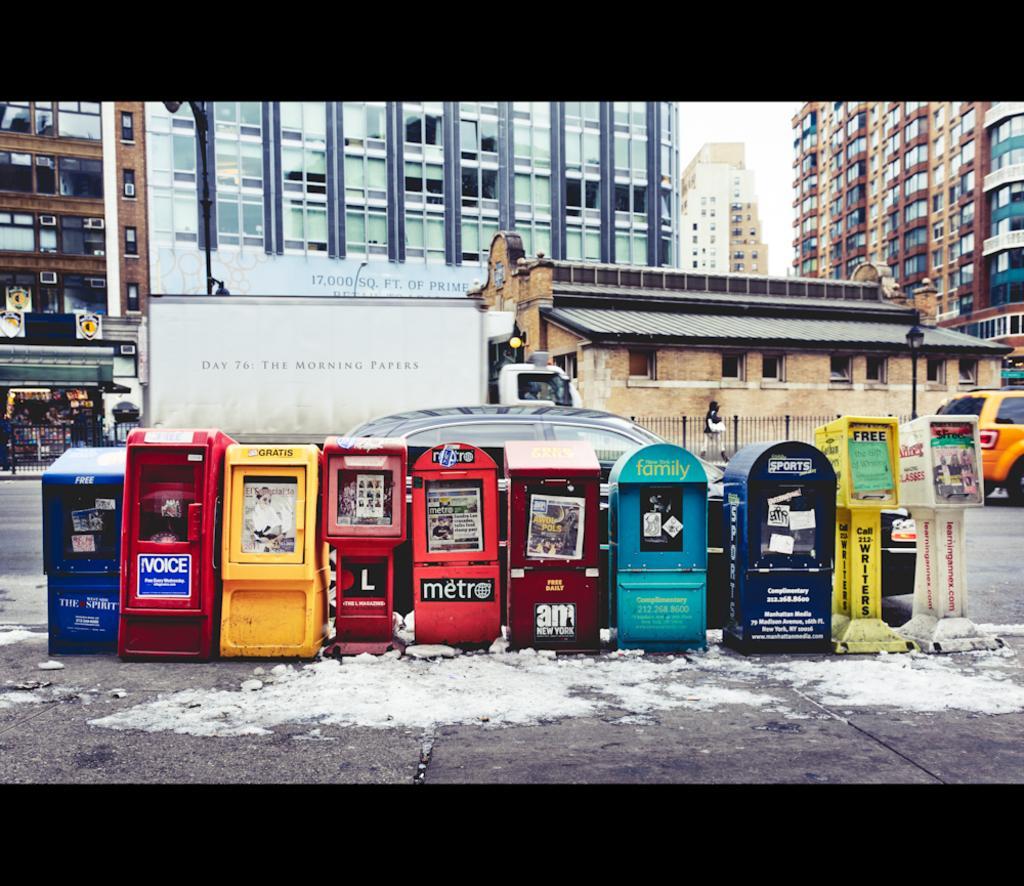Can you describe this image briefly? This image is taken outdoors. At the bottom of the image there is a road and there is a dirt on the road. In the background there are a few buildings. There are many boards with text on them. There is a railing. In the middle of the image a truck is parked on the road. There is a house with walls, windows, doors and a roof. There is a pole with a street light. A person is walking on the road. On the right side of the image a car is moving on the road. In the middle of the image a car is parked on the road and there are a few machines with a text on them. 